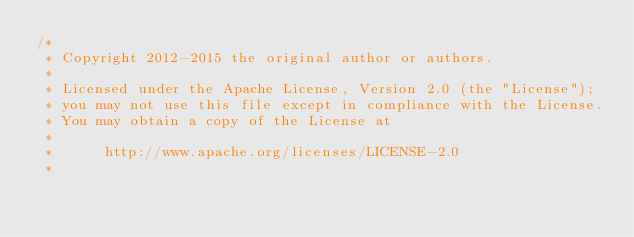Convert code to text. <code><loc_0><loc_0><loc_500><loc_500><_Java_>/*
 * Copyright 2012-2015 the original author or authors.
 *
 * Licensed under the Apache License, Version 2.0 (the "License");
 * you may not use this file except in compliance with the License.
 * You may obtain a copy of the License at
 *
 *      http://www.apache.org/licenses/LICENSE-2.0
 *</code> 